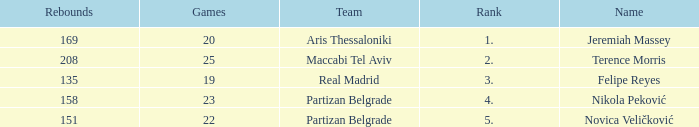How many Games for Terence Morris? 25.0. 